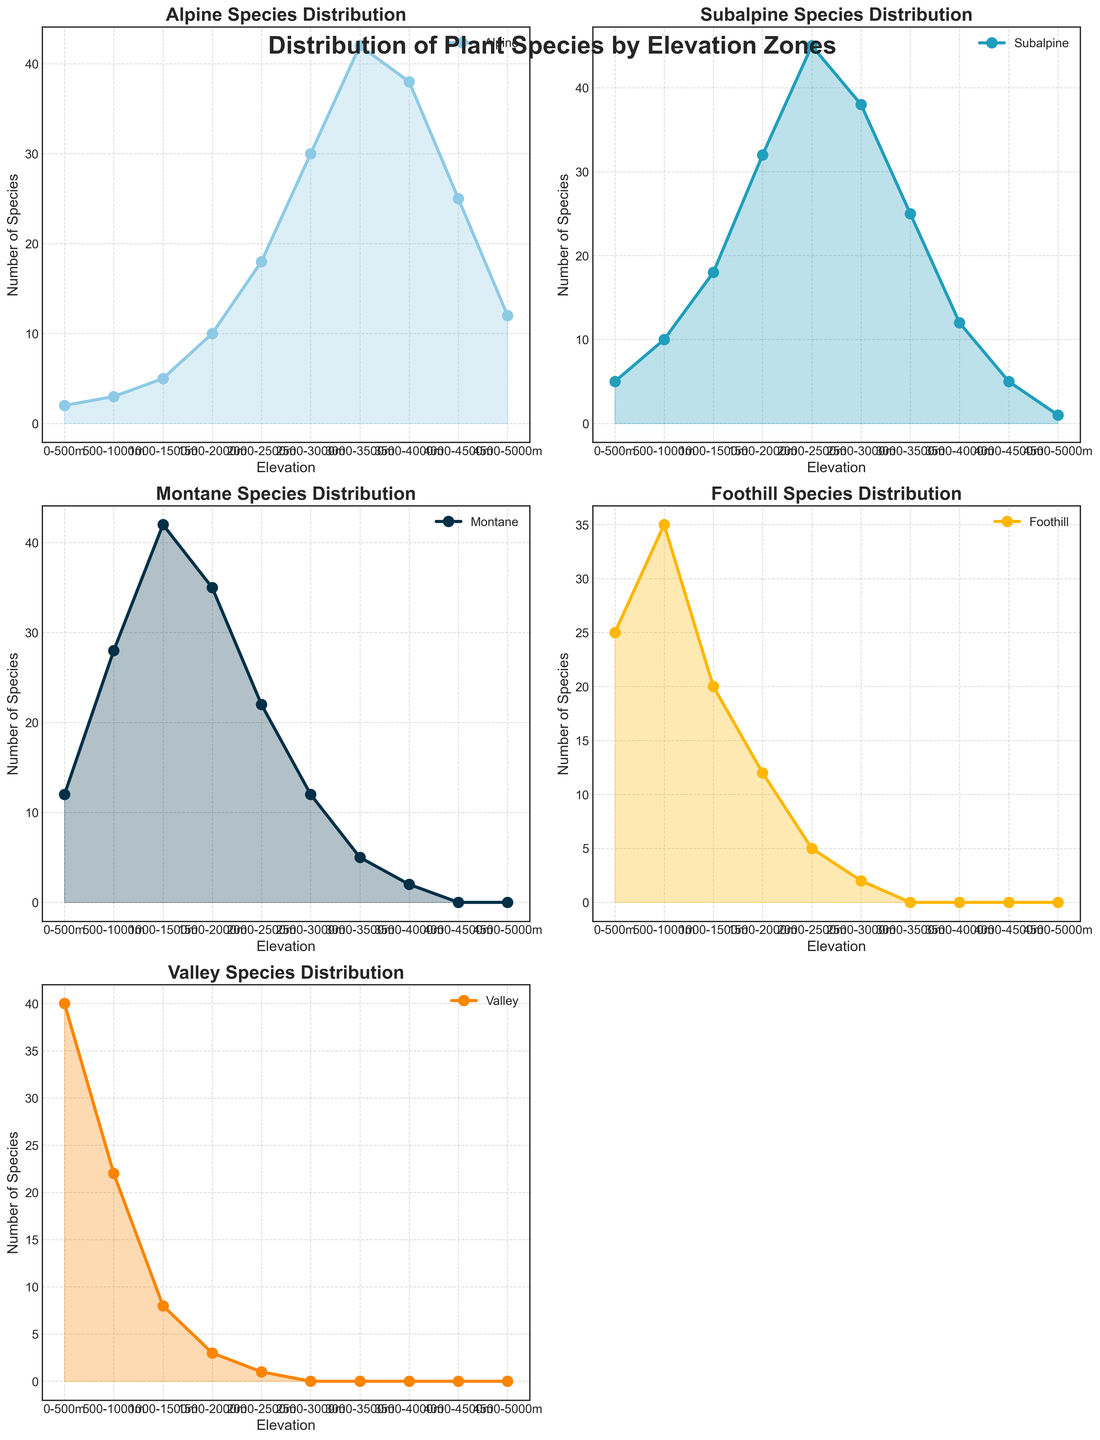Which elevation zone has the highest number of Alpine species? Identify the elevation zone with the maximum value for Alpine species from the Alpine Species Distribution subplot. The highest number is 42 at 3000-3500m.
Answer: 3000-3500m Compare the number of Subalpine species at 1500-2000m with Montane species at the same elevation. Which is higher? In the Subalpine Species Distribution subplot, the number at 1500-2000m is 32. In the Montane Species Distribution subplot, the number at 1500-2000m is 35. Montane species have a higher count.
Answer: Montane What is the sum of Alpine and Subalpine species at 2500-3000m? Identify the values for Alpine (30) and Subalpine (38) species from their respective subplots at 2500-3000m and sum them up: 30 + 38 = 68.
Answer: 68 At which elevation do Foothill species drop to zero? In the Foothill Species Distribution subplot, the number of species drops to zero at elevations 4000-4500m, 4500-5000m.
Answer: 4000-4500m Are there more Valley species at 0-500m or at 1000-1500m? In the Valley Species Distribution subplot, the number at 0-500m is 40, and at 1000-1500m is 8. There are more Valley species at 0-500m.
Answer: 0-500m Which elevation range shows the steepest decline in Montane species? Analyze the Montane Species Distribution subplot to find the steepest drop. The number of species decreases dramatically from 42 at 1000-1500m to 22 at 2000-2500m, indicating the steepest decline.
Answer: 2000-2500m What is the average number of Foothill species across all elevation zones? Sum the number of Foothill species across all elevation zones and divide by the number of zones: (25 + 35 + 20 + 12 + 5 + 2 + 0 + 0 + 0 + 0) / 10 = 99 / 10 = 9.9
Answer: 9.9 How does the distribution of Alpine species compare to that of Valley species? Compare the shape and values of the Alpine and Valley subplots: Alpine species increase with elevation peaking at 3000-3500m then decrease, Valley species decrease sharply from 0-500m upwards.
Answer: Opposite trends Which species shows the most consistent increase with elevation? Observe the trends in each subplot. Alpine species show a consistent increase, peaking at 3000-3500m. The others have more fluctuation or drop-off.
Answer: Alpine 